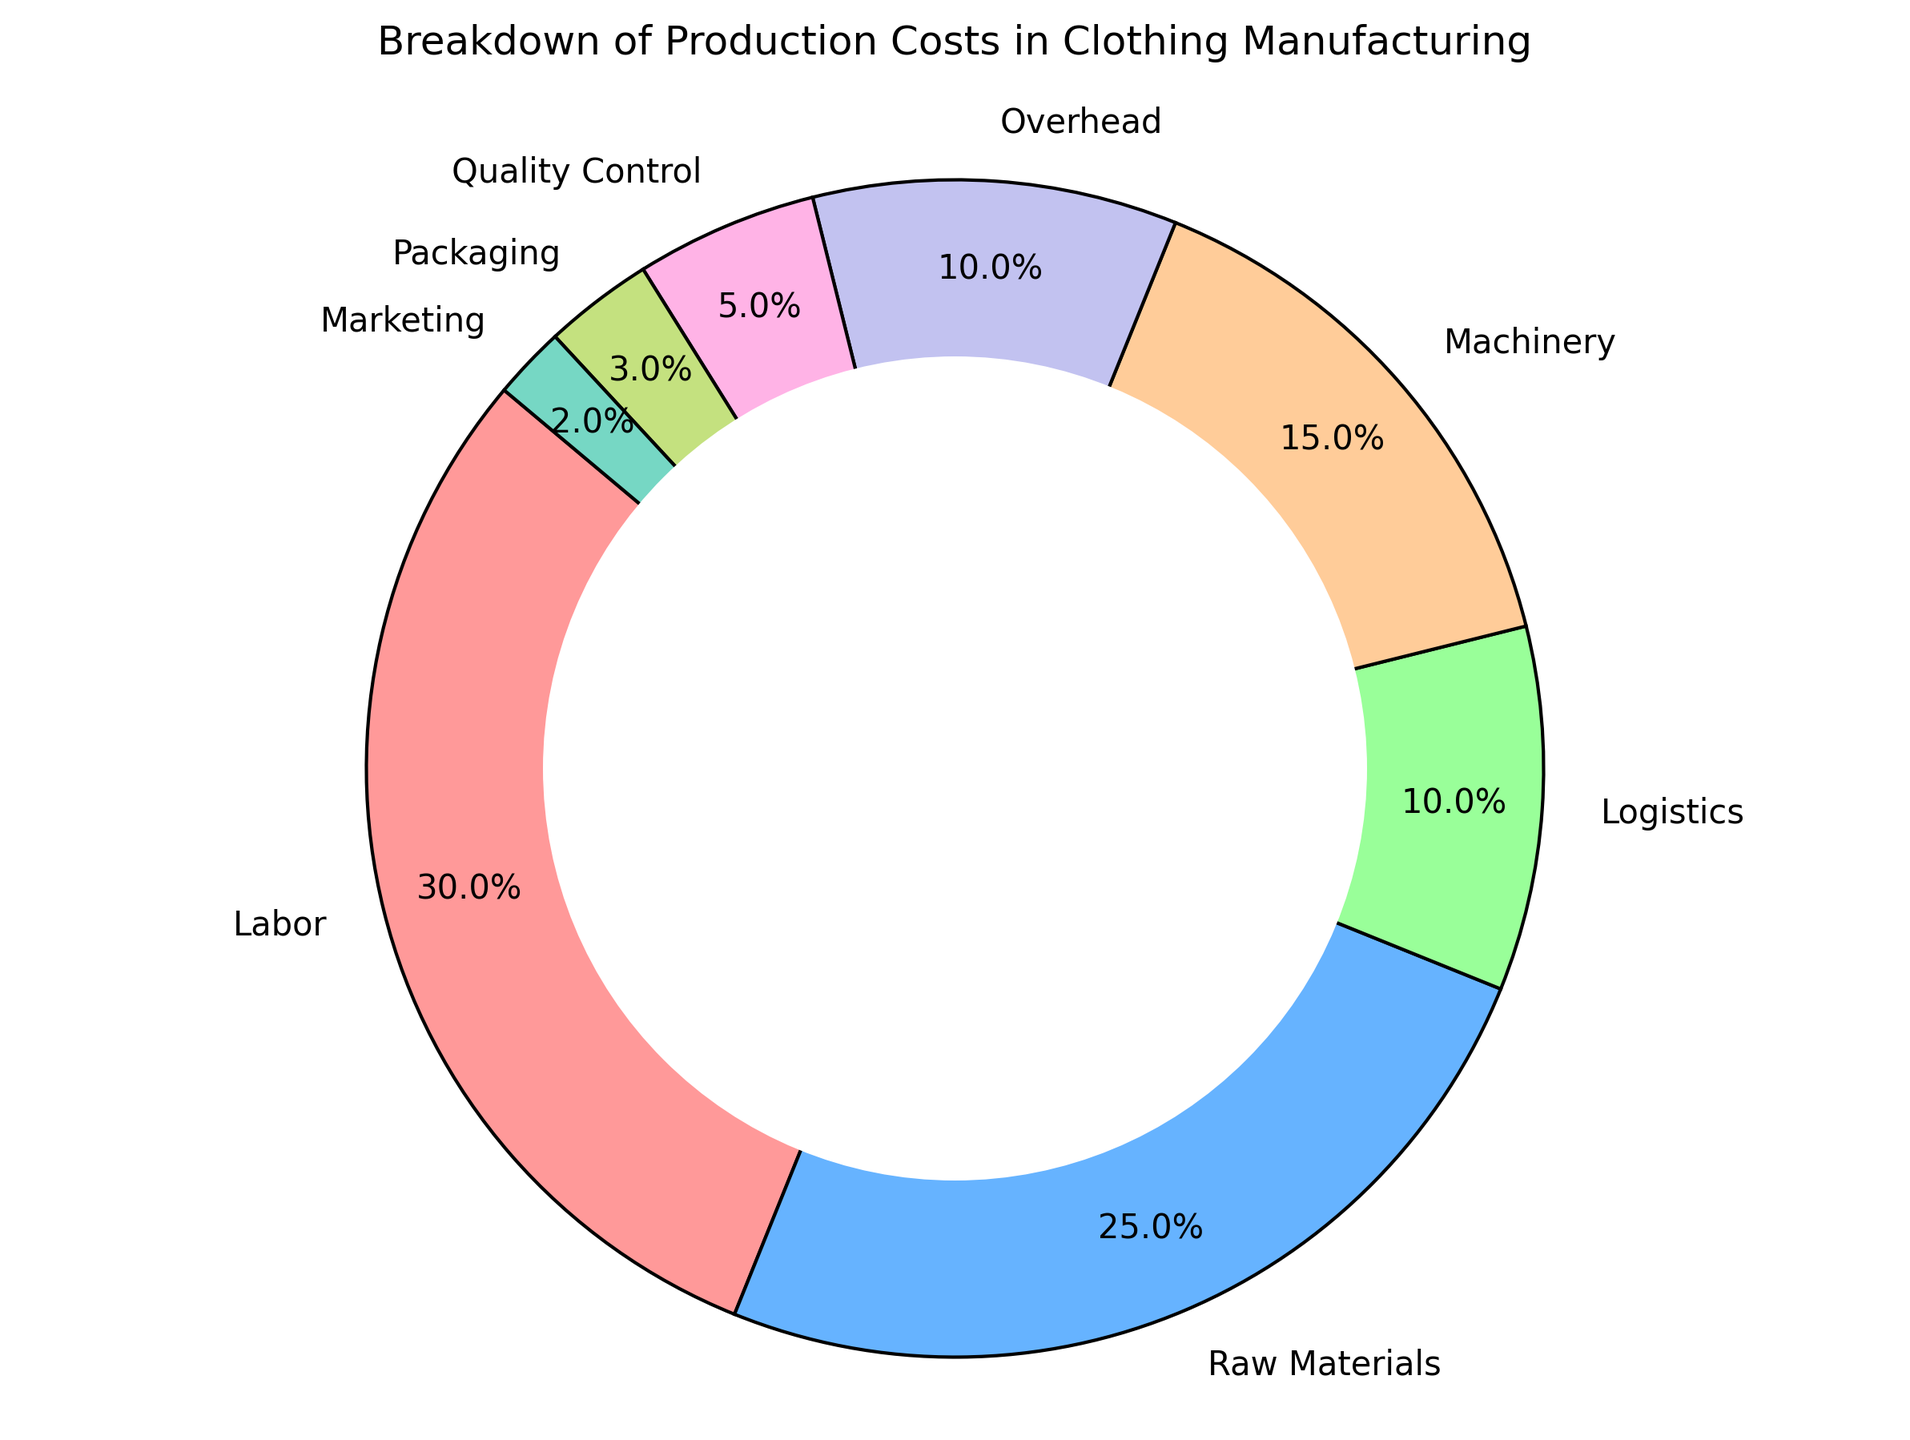What percentage of production costs is attributed to labor and raw materials combined? To find the combined percentage, add the percentages for labor and raw materials: 30% (labor) + 25% (raw materials) = 55%.
Answer: 55% Which category has the smallest percentage of production costs? By observing the pie chart, the category with the smallest segment is marketing, which has 2%.
Answer: Marketing How does the percentage of machinery costs compare to logistics costs? The chart shows that machinery accounts for 15% of production costs, while logistics accounts for 10%. Therefore, machinery costs are greater than logistics costs by 5%.
Answer: Machinery costs are higher What is the difference in percentages between overhead and quality control costs? The percentage for overhead is 10% and for quality control is 5%. The difference is found by subtracting the two values: 10% - 5% = 5%.
Answer: 5% What is the total percentage of costs that are not directly related to production (e.g., including logistics, marketing, and packaging)? Adding the percentages of logistics, marketing, and packaging: 10% (logistics) + 2% (marketing) + 3% (packaging) = 15%.
Answer: 15% Which category has a larger percentage, overhead or quality control? The chart shows that overhead is 10% and quality control is 5%. Thus, overhead has a larger percentage.
Answer: Overhead What is the combined percentage of categories with less than 10% of the total production costs? Adding the percentages of categories with less than 10%: logistics (10%), overhead (10%), quality control (5%), packaging (3%), marketing (2%). Therefore: 10% + 10% + 5% + 3% + 2% = 30%.
Answer: 30% What color represents the packaging cost in the pie chart? The chart uses specific colors for each category. The color associated with packaging is represented by the segment that corresponds to 3%, which is a shade of yellow-green.
Answer: Yellow-green 